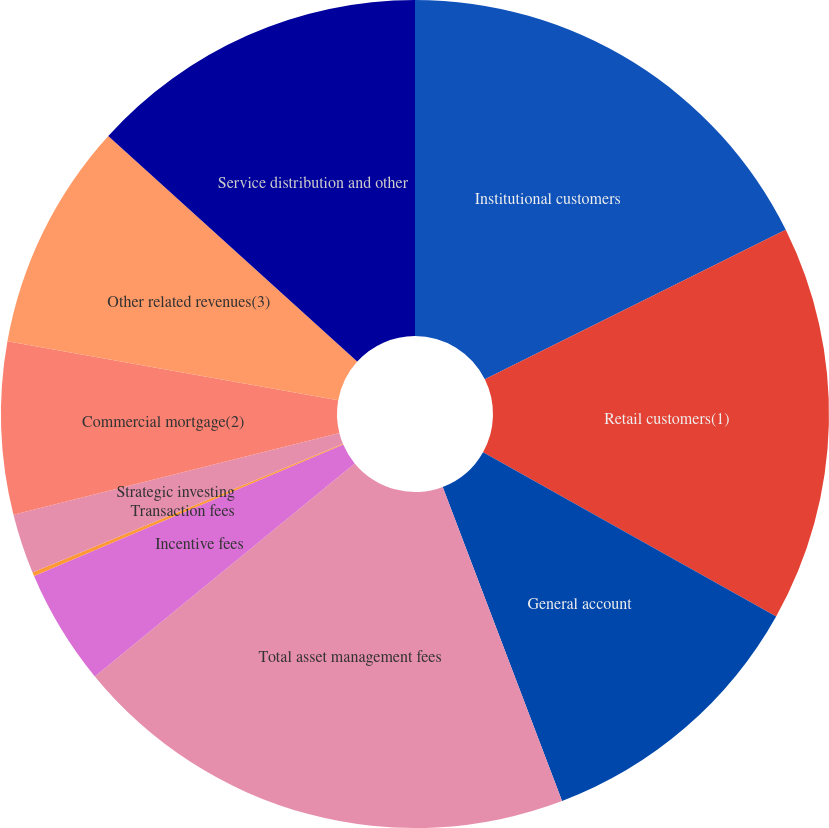Convert chart to OTSL. <chart><loc_0><loc_0><loc_500><loc_500><pie_chart><fcel>Institutional customers<fcel>Retail customers(1)<fcel>General account<fcel>Total asset management fees<fcel>Incentive fees<fcel>Transaction fees<fcel>Strategic investing<fcel>Commercial mortgage(2)<fcel>Other related revenues(3)<fcel>Service distribution and other<nl><fcel>17.66%<fcel>15.47%<fcel>11.09%<fcel>19.85%<fcel>4.53%<fcel>0.15%<fcel>2.34%<fcel>6.72%<fcel>8.91%<fcel>13.28%<nl></chart> 